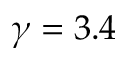<formula> <loc_0><loc_0><loc_500><loc_500>\gamma = 3 . 4</formula> 